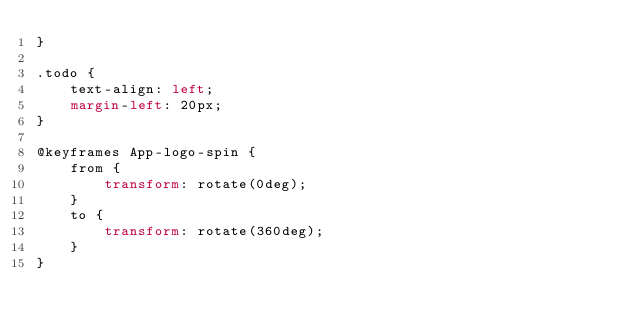<code> <loc_0><loc_0><loc_500><loc_500><_CSS_>}

.todo {
    text-align: left;
    margin-left: 20px;
}

@keyframes App-logo-spin {
    from {
        transform: rotate(0deg);
    }
    to {
        transform: rotate(360deg);
    }
}</code> 